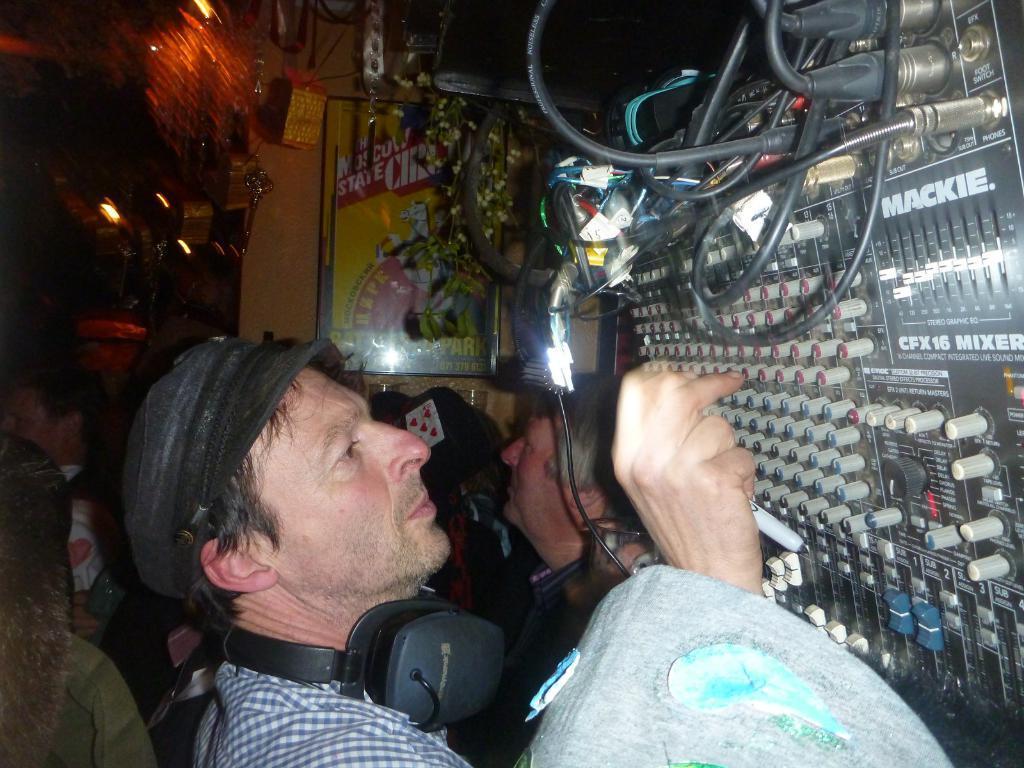Could you give a brief overview of what you see in this image? In this image I can see a group of people on the floor, some objects, wires, lights, boards and so on. This image is taken may be in a hall. 